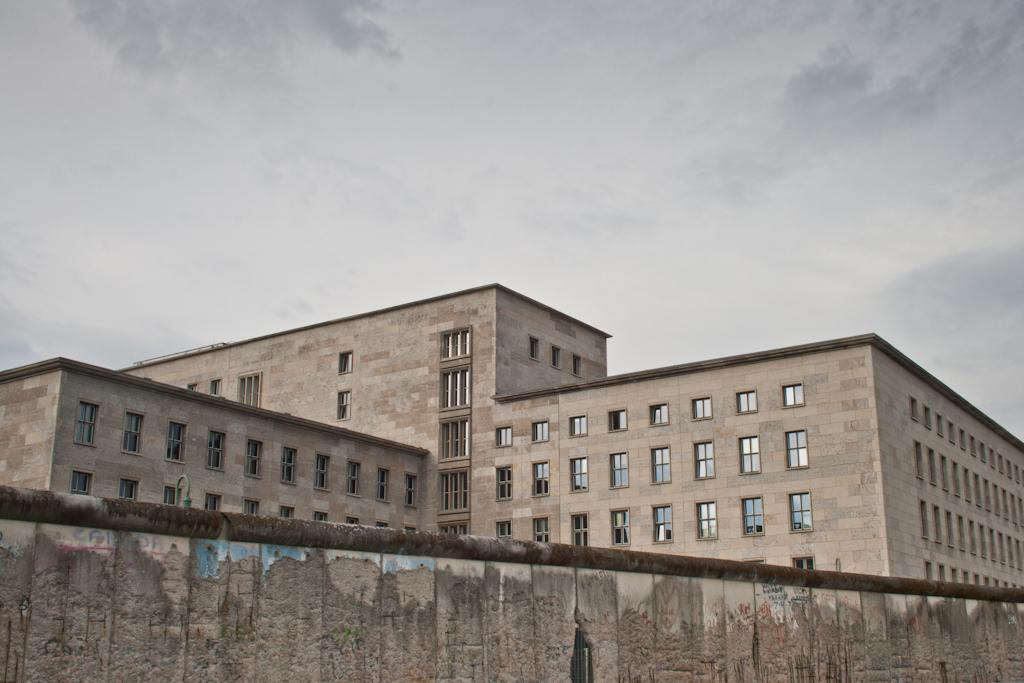What feature can be seen on the building in the image? The building has windows. How would you describe the sky in the image? The sky is cloudy. Can you identify any architectural elements in the image? Yes, there is a wall in the image. What type of bag is hanging on the wall in the image? There is no bag present in the image; only a wall and a building with windows are visible. 